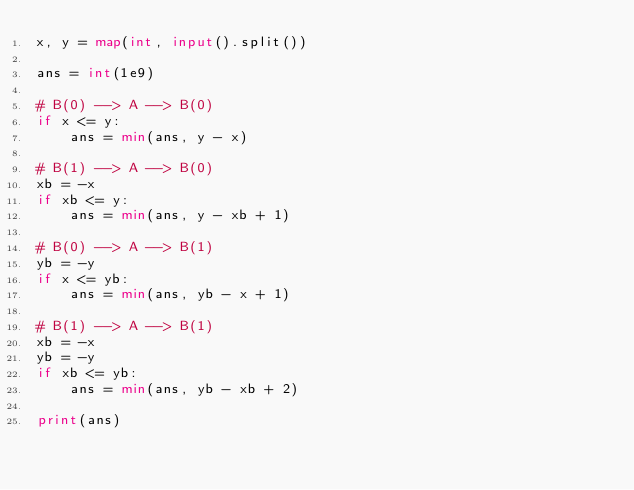<code> <loc_0><loc_0><loc_500><loc_500><_Python_>x, y = map(int, input().split())

ans = int(1e9)

# B(0) --> A --> B(0)
if x <= y:
    ans = min(ans, y - x)

# B(1) --> A --> B(0)
xb = -x
if xb <= y:
    ans = min(ans, y - xb + 1)

# B(0) --> A --> B(1)
yb = -y
if x <= yb:
    ans = min(ans, yb - x + 1)

# B(1) --> A --> B(1)
xb = -x
yb = -y
if xb <= yb:
    ans = min(ans, yb - xb + 2)

print(ans)
</code> 